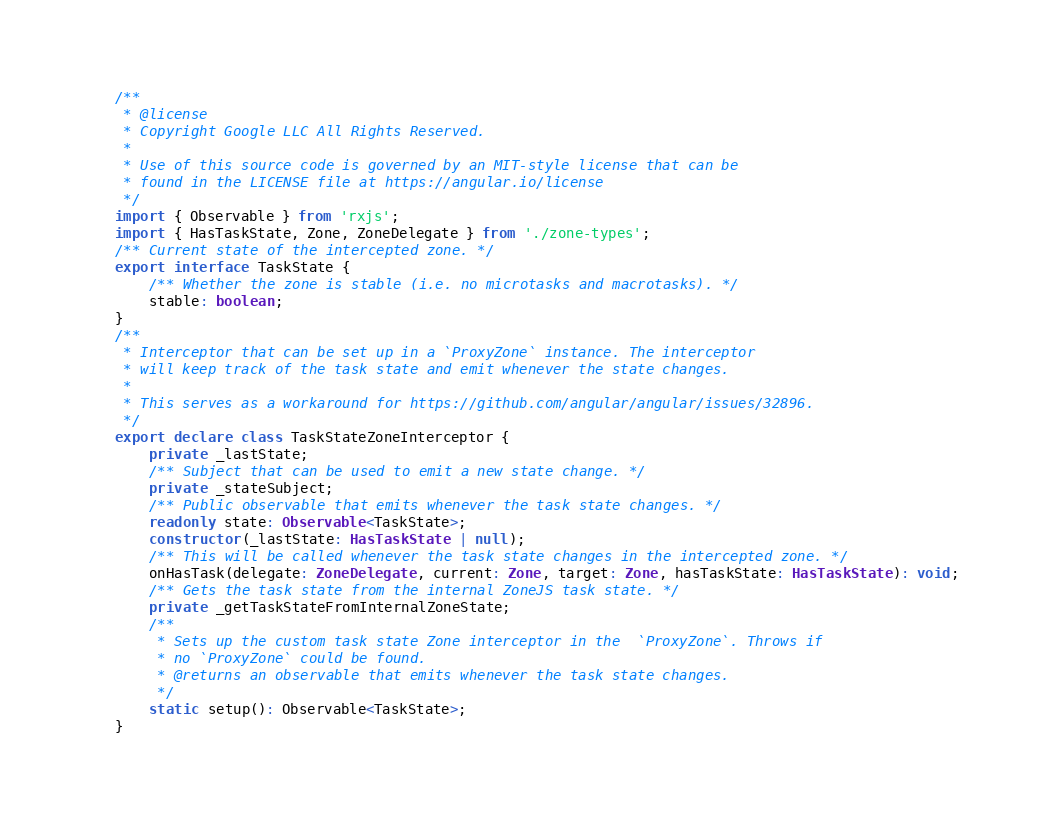Convert code to text. <code><loc_0><loc_0><loc_500><loc_500><_TypeScript_>/**
 * @license
 * Copyright Google LLC All Rights Reserved.
 *
 * Use of this source code is governed by an MIT-style license that can be
 * found in the LICENSE file at https://angular.io/license
 */
import { Observable } from 'rxjs';
import { HasTaskState, Zone, ZoneDelegate } from './zone-types';
/** Current state of the intercepted zone. */
export interface TaskState {
    /** Whether the zone is stable (i.e. no microtasks and macrotasks). */
    stable: boolean;
}
/**
 * Interceptor that can be set up in a `ProxyZone` instance. The interceptor
 * will keep track of the task state and emit whenever the state changes.
 *
 * This serves as a workaround for https://github.com/angular/angular/issues/32896.
 */
export declare class TaskStateZoneInterceptor {
    private _lastState;
    /** Subject that can be used to emit a new state change. */
    private _stateSubject;
    /** Public observable that emits whenever the task state changes. */
    readonly state: Observable<TaskState>;
    constructor(_lastState: HasTaskState | null);
    /** This will be called whenever the task state changes in the intercepted zone. */
    onHasTask(delegate: ZoneDelegate, current: Zone, target: Zone, hasTaskState: HasTaskState): void;
    /** Gets the task state from the internal ZoneJS task state. */
    private _getTaskStateFromInternalZoneState;
    /**
     * Sets up the custom task state Zone interceptor in the  `ProxyZone`. Throws if
     * no `ProxyZone` could be found.
     * @returns an observable that emits whenever the task state changes.
     */
    static setup(): Observable<TaskState>;
}
</code> 